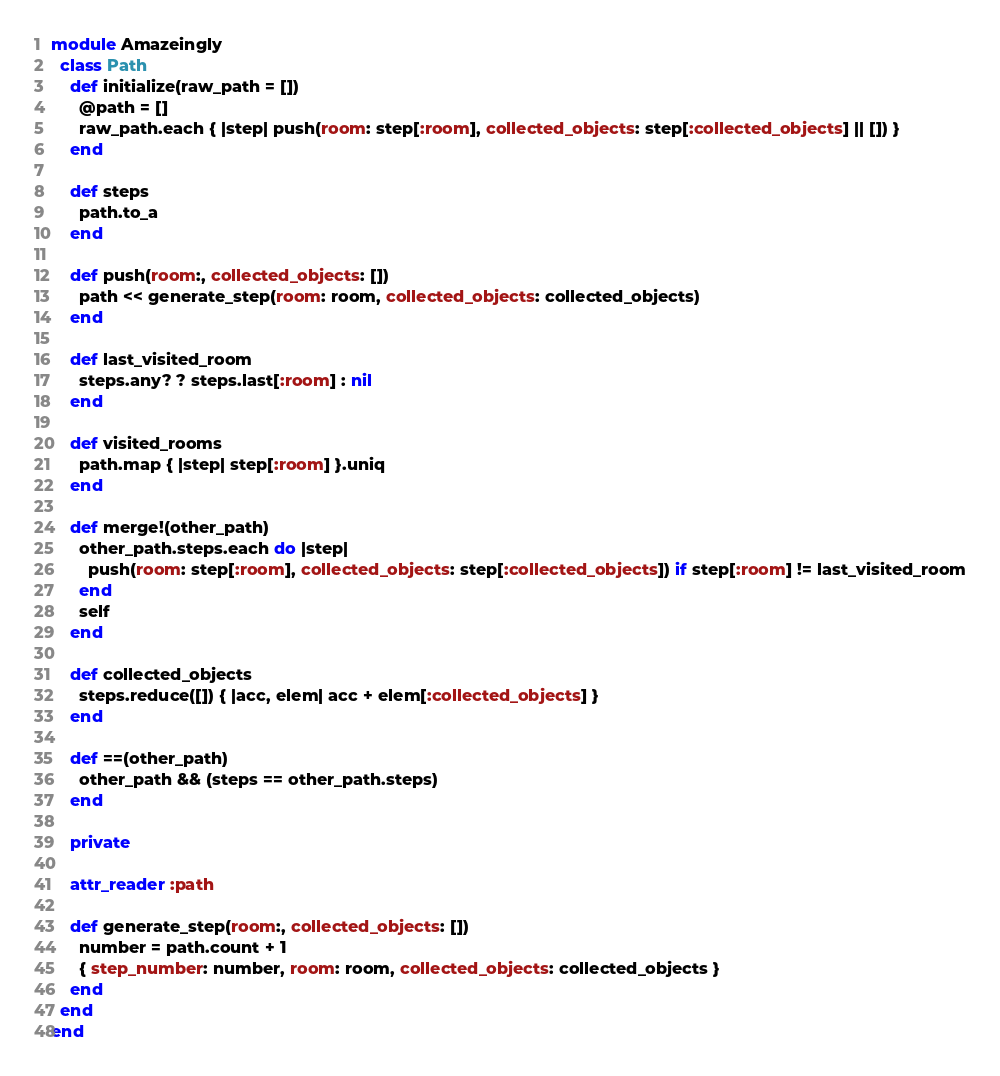<code> <loc_0><loc_0><loc_500><loc_500><_Ruby_>module Amazeingly
  class Path
    def initialize(raw_path = [])
      @path = []
      raw_path.each { |step| push(room: step[:room], collected_objects: step[:collected_objects] || []) }
    end

    def steps
      path.to_a
    end

    def push(room:, collected_objects: [])
      path << generate_step(room: room, collected_objects: collected_objects)
    end

    def last_visited_room
      steps.any? ? steps.last[:room] : nil
    end

    def visited_rooms
      path.map { |step| step[:room] }.uniq
    end

    def merge!(other_path)
      other_path.steps.each do |step|
        push(room: step[:room], collected_objects: step[:collected_objects]) if step[:room] != last_visited_room
      end
      self
    end

    def collected_objects
      steps.reduce([]) { |acc, elem| acc + elem[:collected_objects] }
    end

    def ==(other_path)
      other_path && (steps == other_path.steps)
    end

    private

    attr_reader :path

    def generate_step(room:, collected_objects: [])
      number = path.count + 1
      { step_number: number, room: room, collected_objects: collected_objects }
    end
  end
end
</code> 